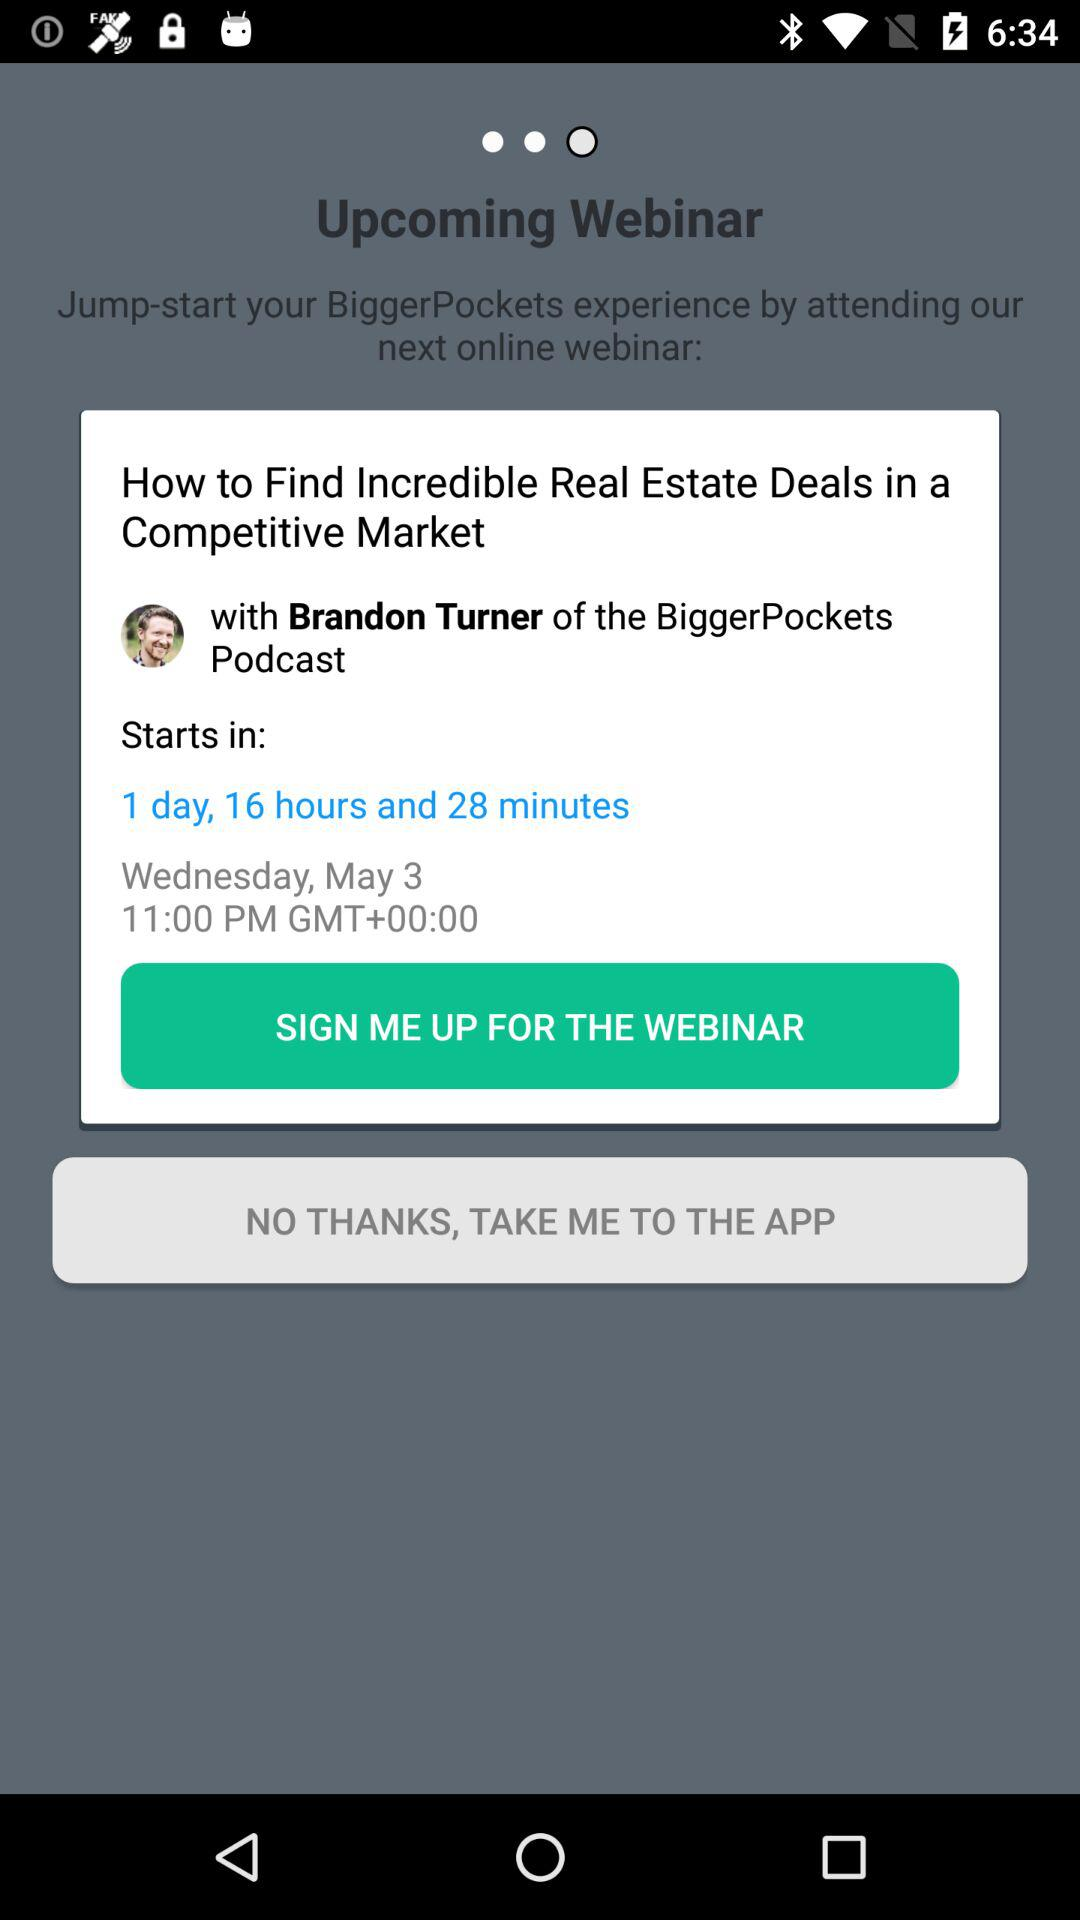How much time is left to start the webinar? The time left to start the webinar is 1 day, 16 hours and 28 minutes. 